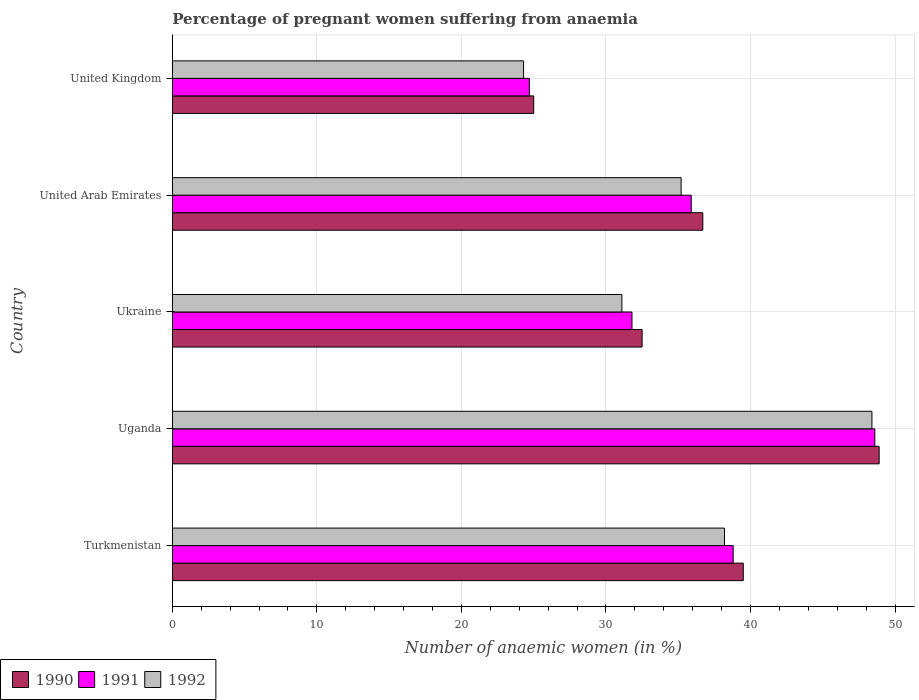How many groups of bars are there?
Offer a terse response. 5. Are the number of bars on each tick of the Y-axis equal?
Ensure brevity in your answer.  Yes. How many bars are there on the 3rd tick from the top?
Your answer should be very brief. 3. How many bars are there on the 4th tick from the bottom?
Your answer should be very brief. 3. What is the label of the 1st group of bars from the top?
Offer a terse response. United Kingdom. What is the number of anaemic women in 1991 in Turkmenistan?
Your response must be concise. 38.8. Across all countries, what is the maximum number of anaemic women in 1990?
Offer a very short reply. 48.9. Across all countries, what is the minimum number of anaemic women in 1991?
Your response must be concise. 24.7. In which country was the number of anaemic women in 1992 maximum?
Your answer should be compact. Uganda. In which country was the number of anaemic women in 1990 minimum?
Your answer should be very brief. United Kingdom. What is the total number of anaemic women in 1992 in the graph?
Make the answer very short. 177.2. What is the difference between the number of anaemic women in 1991 in Uganda and that in United Arab Emirates?
Provide a succinct answer. 12.7. What is the difference between the number of anaemic women in 1991 in Uganda and the number of anaemic women in 1992 in United Kingdom?
Offer a terse response. 24.3. What is the average number of anaemic women in 1992 per country?
Give a very brief answer. 35.44. What is the difference between the number of anaemic women in 1992 and number of anaemic women in 1991 in Turkmenistan?
Your answer should be very brief. -0.6. In how many countries, is the number of anaemic women in 1992 greater than 26 %?
Ensure brevity in your answer.  4. What is the ratio of the number of anaemic women in 1992 in Turkmenistan to that in Ukraine?
Make the answer very short. 1.23. Is the difference between the number of anaemic women in 1992 in Ukraine and United Kingdom greater than the difference between the number of anaemic women in 1991 in Ukraine and United Kingdom?
Provide a succinct answer. No. What is the difference between the highest and the second highest number of anaemic women in 1992?
Offer a terse response. 10.2. What is the difference between the highest and the lowest number of anaemic women in 1992?
Offer a very short reply. 24.1. Is the sum of the number of anaemic women in 1992 in Turkmenistan and United Arab Emirates greater than the maximum number of anaemic women in 1990 across all countries?
Keep it short and to the point. Yes. What does the 1st bar from the bottom in Ukraine represents?
Your answer should be compact. 1990. How many bars are there?
Make the answer very short. 15. Are all the bars in the graph horizontal?
Keep it short and to the point. Yes. What is the difference between two consecutive major ticks on the X-axis?
Your answer should be very brief. 10. Does the graph contain grids?
Give a very brief answer. Yes. Where does the legend appear in the graph?
Your answer should be very brief. Bottom left. How many legend labels are there?
Your answer should be very brief. 3. What is the title of the graph?
Your answer should be very brief. Percentage of pregnant women suffering from anaemia. What is the label or title of the X-axis?
Give a very brief answer. Number of anaemic women (in %). What is the label or title of the Y-axis?
Your answer should be compact. Country. What is the Number of anaemic women (in %) of 1990 in Turkmenistan?
Keep it short and to the point. 39.5. What is the Number of anaemic women (in %) in 1991 in Turkmenistan?
Your response must be concise. 38.8. What is the Number of anaemic women (in %) in 1992 in Turkmenistan?
Make the answer very short. 38.2. What is the Number of anaemic women (in %) of 1990 in Uganda?
Make the answer very short. 48.9. What is the Number of anaemic women (in %) of 1991 in Uganda?
Offer a very short reply. 48.6. What is the Number of anaemic women (in %) in 1992 in Uganda?
Provide a short and direct response. 48.4. What is the Number of anaemic women (in %) in 1990 in Ukraine?
Give a very brief answer. 32.5. What is the Number of anaemic women (in %) of 1991 in Ukraine?
Make the answer very short. 31.8. What is the Number of anaemic women (in %) in 1992 in Ukraine?
Offer a terse response. 31.1. What is the Number of anaemic women (in %) of 1990 in United Arab Emirates?
Make the answer very short. 36.7. What is the Number of anaemic women (in %) of 1991 in United Arab Emirates?
Offer a terse response. 35.9. What is the Number of anaemic women (in %) in 1992 in United Arab Emirates?
Provide a succinct answer. 35.2. What is the Number of anaemic women (in %) of 1990 in United Kingdom?
Provide a succinct answer. 25. What is the Number of anaemic women (in %) of 1991 in United Kingdom?
Your answer should be very brief. 24.7. What is the Number of anaemic women (in %) of 1992 in United Kingdom?
Your answer should be very brief. 24.3. Across all countries, what is the maximum Number of anaemic women (in %) of 1990?
Keep it short and to the point. 48.9. Across all countries, what is the maximum Number of anaemic women (in %) of 1991?
Your answer should be very brief. 48.6. Across all countries, what is the maximum Number of anaemic women (in %) in 1992?
Provide a succinct answer. 48.4. Across all countries, what is the minimum Number of anaemic women (in %) of 1991?
Provide a short and direct response. 24.7. Across all countries, what is the minimum Number of anaemic women (in %) in 1992?
Your response must be concise. 24.3. What is the total Number of anaemic women (in %) of 1990 in the graph?
Provide a short and direct response. 182.6. What is the total Number of anaemic women (in %) in 1991 in the graph?
Make the answer very short. 179.8. What is the total Number of anaemic women (in %) in 1992 in the graph?
Give a very brief answer. 177.2. What is the difference between the Number of anaemic women (in %) in 1990 in Turkmenistan and that in Uganda?
Offer a very short reply. -9.4. What is the difference between the Number of anaemic women (in %) in 1991 in Turkmenistan and that in Uganda?
Ensure brevity in your answer.  -9.8. What is the difference between the Number of anaemic women (in %) in 1992 in Turkmenistan and that in Uganda?
Offer a very short reply. -10.2. What is the difference between the Number of anaemic women (in %) in 1990 in Turkmenistan and that in Ukraine?
Your response must be concise. 7. What is the difference between the Number of anaemic women (in %) of 1990 in Turkmenistan and that in United Arab Emirates?
Offer a terse response. 2.8. What is the difference between the Number of anaemic women (in %) in 1992 in Turkmenistan and that in United Arab Emirates?
Your response must be concise. 3. What is the difference between the Number of anaemic women (in %) in 1990 in Turkmenistan and that in United Kingdom?
Provide a short and direct response. 14.5. What is the difference between the Number of anaemic women (in %) of 1991 in Turkmenistan and that in United Kingdom?
Make the answer very short. 14.1. What is the difference between the Number of anaemic women (in %) in 1992 in Turkmenistan and that in United Kingdom?
Provide a short and direct response. 13.9. What is the difference between the Number of anaemic women (in %) of 1990 in Uganda and that in Ukraine?
Provide a short and direct response. 16.4. What is the difference between the Number of anaemic women (in %) of 1991 in Uganda and that in Ukraine?
Your response must be concise. 16.8. What is the difference between the Number of anaemic women (in %) in 1990 in Uganda and that in United Arab Emirates?
Offer a very short reply. 12.2. What is the difference between the Number of anaemic women (in %) in 1990 in Uganda and that in United Kingdom?
Give a very brief answer. 23.9. What is the difference between the Number of anaemic women (in %) of 1991 in Uganda and that in United Kingdom?
Your response must be concise. 23.9. What is the difference between the Number of anaemic women (in %) in 1992 in Uganda and that in United Kingdom?
Give a very brief answer. 24.1. What is the difference between the Number of anaemic women (in %) in 1990 in Ukraine and that in United Arab Emirates?
Offer a very short reply. -4.2. What is the difference between the Number of anaemic women (in %) of 1991 in Ukraine and that in United Arab Emirates?
Offer a very short reply. -4.1. What is the difference between the Number of anaemic women (in %) in 1991 in Ukraine and that in United Kingdom?
Offer a terse response. 7.1. What is the difference between the Number of anaemic women (in %) in 1992 in Ukraine and that in United Kingdom?
Keep it short and to the point. 6.8. What is the difference between the Number of anaemic women (in %) in 1990 in United Arab Emirates and that in United Kingdom?
Make the answer very short. 11.7. What is the difference between the Number of anaemic women (in %) in 1991 in United Arab Emirates and that in United Kingdom?
Offer a terse response. 11.2. What is the difference between the Number of anaemic women (in %) in 1992 in United Arab Emirates and that in United Kingdom?
Keep it short and to the point. 10.9. What is the difference between the Number of anaemic women (in %) of 1990 in Turkmenistan and the Number of anaemic women (in %) of 1991 in Uganda?
Your response must be concise. -9.1. What is the difference between the Number of anaemic women (in %) of 1990 in Turkmenistan and the Number of anaemic women (in %) of 1992 in Uganda?
Your response must be concise. -8.9. What is the difference between the Number of anaemic women (in %) of 1991 in Turkmenistan and the Number of anaemic women (in %) of 1992 in Uganda?
Provide a succinct answer. -9.6. What is the difference between the Number of anaemic women (in %) in 1990 in Turkmenistan and the Number of anaemic women (in %) in 1991 in United Arab Emirates?
Your answer should be very brief. 3.6. What is the difference between the Number of anaemic women (in %) in 1991 in Turkmenistan and the Number of anaemic women (in %) in 1992 in United Arab Emirates?
Keep it short and to the point. 3.6. What is the difference between the Number of anaemic women (in %) in 1990 in Turkmenistan and the Number of anaemic women (in %) in 1991 in United Kingdom?
Make the answer very short. 14.8. What is the difference between the Number of anaemic women (in %) of 1990 in Turkmenistan and the Number of anaemic women (in %) of 1992 in United Kingdom?
Give a very brief answer. 15.2. What is the difference between the Number of anaemic women (in %) in 1991 in Turkmenistan and the Number of anaemic women (in %) in 1992 in United Kingdom?
Provide a succinct answer. 14.5. What is the difference between the Number of anaemic women (in %) of 1990 in Uganda and the Number of anaemic women (in %) of 1991 in Ukraine?
Make the answer very short. 17.1. What is the difference between the Number of anaemic women (in %) of 1990 in Uganda and the Number of anaemic women (in %) of 1992 in United Arab Emirates?
Give a very brief answer. 13.7. What is the difference between the Number of anaemic women (in %) in 1991 in Uganda and the Number of anaemic women (in %) in 1992 in United Arab Emirates?
Provide a short and direct response. 13.4. What is the difference between the Number of anaemic women (in %) in 1990 in Uganda and the Number of anaemic women (in %) in 1991 in United Kingdom?
Your response must be concise. 24.2. What is the difference between the Number of anaemic women (in %) in 1990 in Uganda and the Number of anaemic women (in %) in 1992 in United Kingdom?
Ensure brevity in your answer.  24.6. What is the difference between the Number of anaemic women (in %) in 1991 in Uganda and the Number of anaemic women (in %) in 1992 in United Kingdom?
Your answer should be compact. 24.3. What is the difference between the Number of anaemic women (in %) in 1990 in Ukraine and the Number of anaemic women (in %) in 1992 in United Arab Emirates?
Make the answer very short. -2.7. What is the difference between the Number of anaemic women (in %) of 1991 in Ukraine and the Number of anaemic women (in %) of 1992 in United Arab Emirates?
Provide a short and direct response. -3.4. What is the difference between the Number of anaemic women (in %) in 1990 in Ukraine and the Number of anaemic women (in %) in 1992 in United Kingdom?
Offer a very short reply. 8.2. What is the difference between the Number of anaemic women (in %) of 1991 in Ukraine and the Number of anaemic women (in %) of 1992 in United Kingdom?
Offer a very short reply. 7.5. What is the average Number of anaemic women (in %) of 1990 per country?
Your answer should be compact. 36.52. What is the average Number of anaemic women (in %) of 1991 per country?
Make the answer very short. 35.96. What is the average Number of anaemic women (in %) of 1992 per country?
Your response must be concise. 35.44. What is the difference between the Number of anaemic women (in %) in 1991 and Number of anaemic women (in %) in 1992 in Turkmenistan?
Make the answer very short. 0.6. What is the difference between the Number of anaemic women (in %) in 1990 and Number of anaemic women (in %) in 1991 in Uganda?
Provide a short and direct response. 0.3. What is the difference between the Number of anaemic women (in %) in 1991 and Number of anaemic women (in %) in 1992 in Uganda?
Your answer should be compact. 0.2. What is the difference between the Number of anaemic women (in %) of 1990 and Number of anaemic women (in %) of 1992 in United Arab Emirates?
Your answer should be compact. 1.5. What is the ratio of the Number of anaemic women (in %) in 1990 in Turkmenistan to that in Uganda?
Your answer should be compact. 0.81. What is the ratio of the Number of anaemic women (in %) of 1991 in Turkmenistan to that in Uganda?
Make the answer very short. 0.8. What is the ratio of the Number of anaemic women (in %) of 1992 in Turkmenistan to that in Uganda?
Make the answer very short. 0.79. What is the ratio of the Number of anaemic women (in %) of 1990 in Turkmenistan to that in Ukraine?
Your answer should be compact. 1.22. What is the ratio of the Number of anaemic women (in %) of 1991 in Turkmenistan to that in Ukraine?
Provide a short and direct response. 1.22. What is the ratio of the Number of anaemic women (in %) of 1992 in Turkmenistan to that in Ukraine?
Give a very brief answer. 1.23. What is the ratio of the Number of anaemic women (in %) of 1990 in Turkmenistan to that in United Arab Emirates?
Ensure brevity in your answer.  1.08. What is the ratio of the Number of anaemic women (in %) in 1991 in Turkmenistan to that in United Arab Emirates?
Offer a very short reply. 1.08. What is the ratio of the Number of anaemic women (in %) in 1992 in Turkmenistan to that in United Arab Emirates?
Ensure brevity in your answer.  1.09. What is the ratio of the Number of anaemic women (in %) in 1990 in Turkmenistan to that in United Kingdom?
Your answer should be very brief. 1.58. What is the ratio of the Number of anaemic women (in %) of 1991 in Turkmenistan to that in United Kingdom?
Ensure brevity in your answer.  1.57. What is the ratio of the Number of anaemic women (in %) of 1992 in Turkmenistan to that in United Kingdom?
Ensure brevity in your answer.  1.57. What is the ratio of the Number of anaemic women (in %) of 1990 in Uganda to that in Ukraine?
Keep it short and to the point. 1.5. What is the ratio of the Number of anaemic women (in %) in 1991 in Uganda to that in Ukraine?
Offer a very short reply. 1.53. What is the ratio of the Number of anaemic women (in %) of 1992 in Uganda to that in Ukraine?
Ensure brevity in your answer.  1.56. What is the ratio of the Number of anaemic women (in %) of 1990 in Uganda to that in United Arab Emirates?
Offer a very short reply. 1.33. What is the ratio of the Number of anaemic women (in %) in 1991 in Uganda to that in United Arab Emirates?
Ensure brevity in your answer.  1.35. What is the ratio of the Number of anaemic women (in %) in 1992 in Uganda to that in United Arab Emirates?
Offer a very short reply. 1.38. What is the ratio of the Number of anaemic women (in %) of 1990 in Uganda to that in United Kingdom?
Offer a terse response. 1.96. What is the ratio of the Number of anaemic women (in %) in 1991 in Uganda to that in United Kingdom?
Provide a succinct answer. 1.97. What is the ratio of the Number of anaemic women (in %) in 1992 in Uganda to that in United Kingdom?
Provide a succinct answer. 1.99. What is the ratio of the Number of anaemic women (in %) of 1990 in Ukraine to that in United Arab Emirates?
Offer a terse response. 0.89. What is the ratio of the Number of anaemic women (in %) in 1991 in Ukraine to that in United Arab Emirates?
Your answer should be very brief. 0.89. What is the ratio of the Number of anaemic women (in %) in 1992 in Ukraine to that in United Arab Emirates?
Your answer should be compact. 0.88. What is the ratio of the Number of anaemic women (in %) in 1990 in Ukraine to that in United Kingdom?
Offer a terse response. 1.3. What is the ratio of the Number of anaemic women (in %) of 1991 in Ukraine to that in United Kingdom?
Give a very brief answer. 1.29. What is the ratio of the Number of anaemic women (in %) of 1992 in Ukraine to that in United Kingdom?
Offer a very short reply. 1.28. What is the ratio of the Number of anaemic women (in %) in 1990 in United Arab Emirates to that in United Kingdom?
Offer a terse response. 1.47. What is the ratio of the Number of anaemic women (in %) in 1991 in United Arab Emirates to that in United Kingdom?
Keep it short and to the point. 1.45. What is the ratio of the Number of anaemic women (in %) in 1992 in United Arab Emirates to that in United Kingdom?
Your response must be concise. 1.45. What is the difference between the highest and the second highest Number of anaemic women (in %) in 1990?
Provide a succinct answer. 9.4. What is the difference between the highest and the second highest Number of anaemic women (in %) in 1992?
Your answer should be very brief. 10.2. What is the difference between the highest and the lowest Number of anaemic women (in %) of 1990?
Your answer should be very brief. 23.9. What is the difference between the highest and the lowest Number of anaemic women (in %) in 1991?
Give a very brief answer. 23.9. What is the difference between the highest and the lowest Number of anaemic women (in %) in 1992?
Provide a succinct answer. 24.1. 